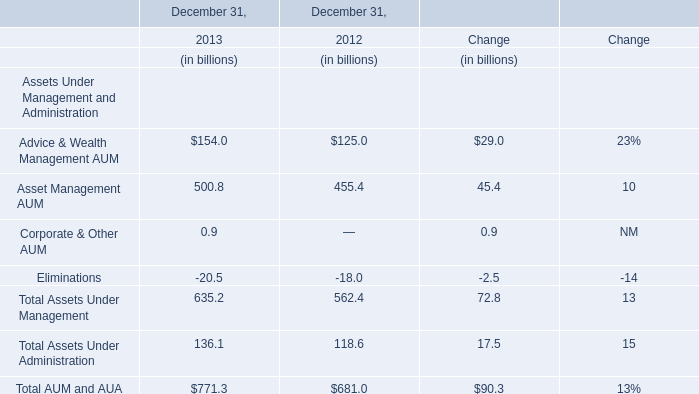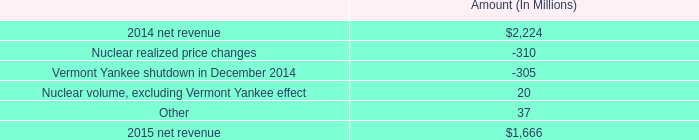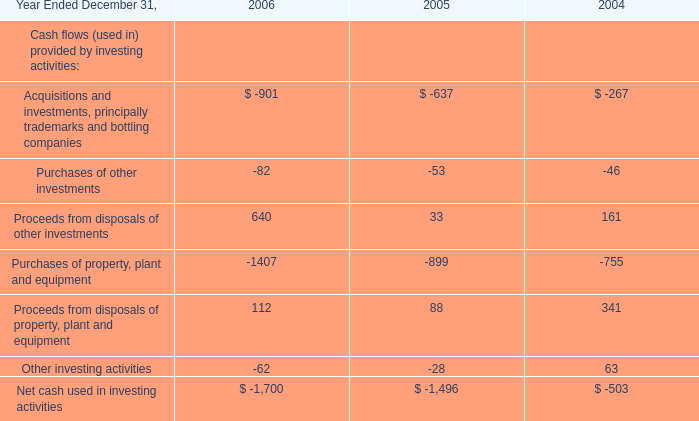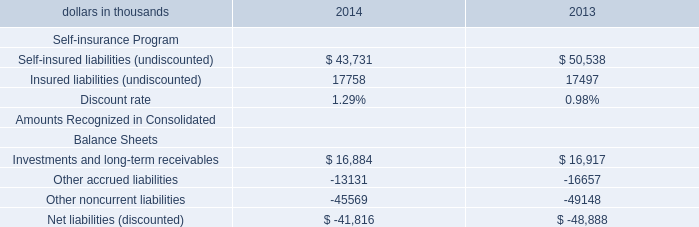what is the growth rate of net revenue from 2014 to 2015 for entergy wholesale commodities? 
Computations: ((1666 - 2224) / 2224)
Answer: -0.2509. 